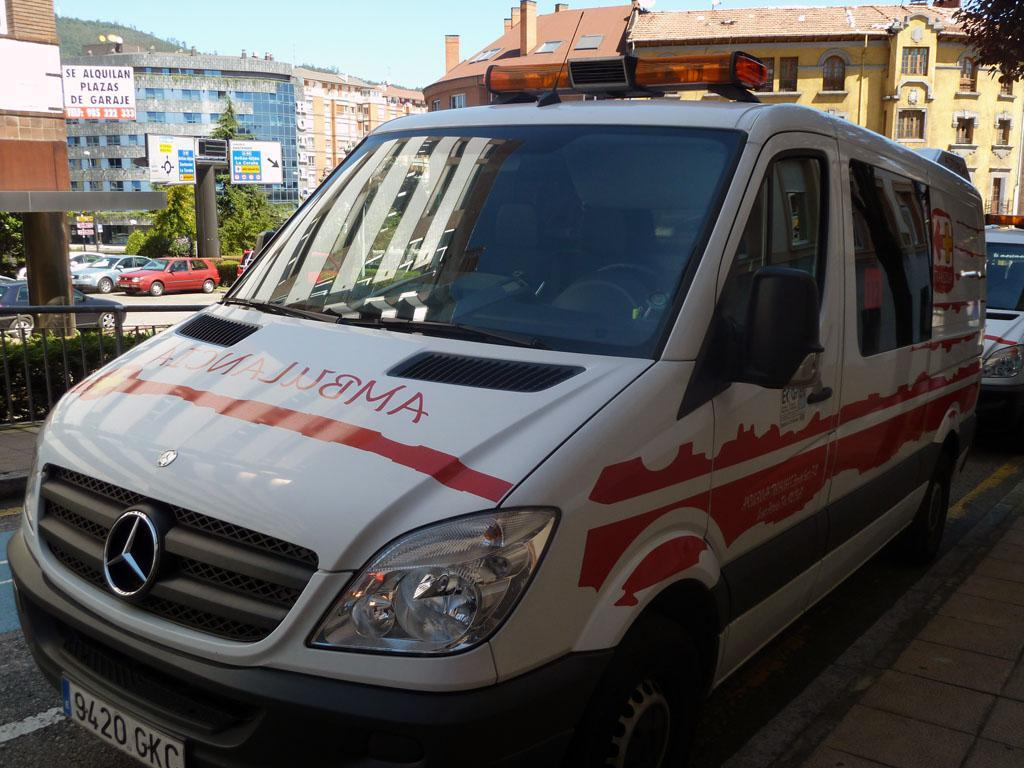Provide a one-sentence caption for the provided image. A vehicle with the word ambulance written on the bonnet. 